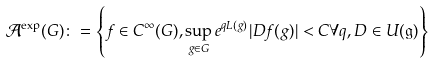<formula> <loc_0><loc_0><loc_500><loc_500>\mathcal { A } ^ { \exp } ( G ) \colon = \left \{ f \in C ^ { \infty } ( G ) , \sup _ { g \in G } e ^ { q L ( g ) } | D f ( g ) | < C \forall q , D \in U ( \mathfrak { g } ) \right \}</formula> 